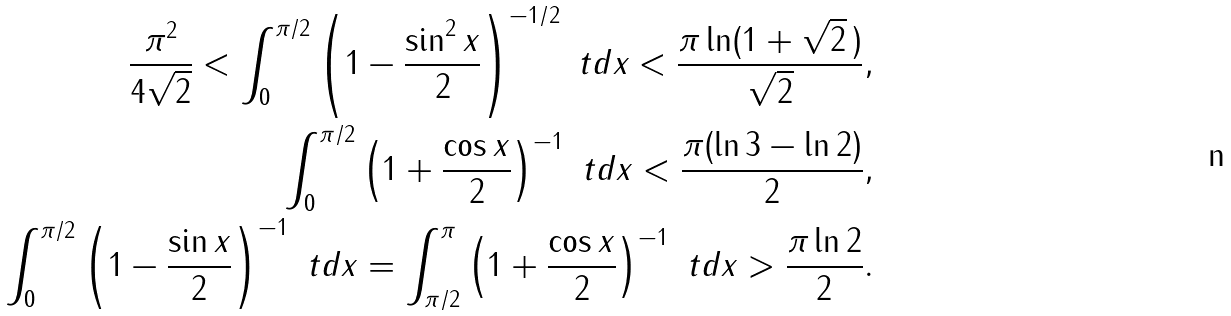Convert formula to latex. <formula><loc_0><loc_0><loc_500><loc_500>\frac { \pi ^ { 2 } } { 4 \sqrt { 2 } } < \int _ { 0 } ^ { \pi / 2 } \left ( 1 - \frac { \sin ^ { 2 } x } { 2 } \right ) ^ { - 1 / 2 } \ t d x < \frac { \pi \ln ( 1 + \sqrt { 2 } \, ) } { \sqrt { 2 } } , \\ \int _ { 0 } ^ { \pi / 2 } \left ( 1 + \frac { \cos x } { 2 } \right ) ^ { - 1 } \ t d x < \frac { \pi ( \ln 3 - \ln 2 ) } { 2 } , \\ \int _ { 0 } ^ { \pi / 2 } \left ( 1 - \frac { \sin x } { 2 } \right ) ^ { - 1 } \ t d x = \int _ { \pi / 2 } ^ { \pi } \left ( 1 + \frac { \cos x } { 2 } \right ) ^ { - 1 } \ t d x > \frac { \pi \ln 2 } { 2 } .</formula> 